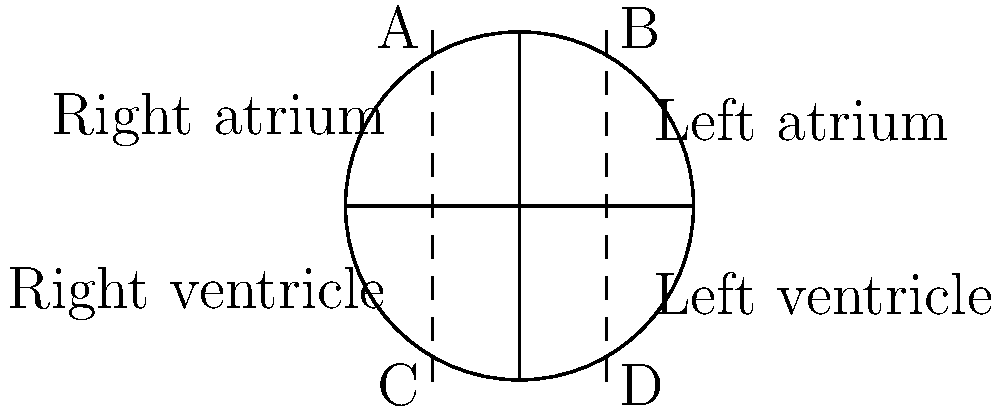In the diagram of the human heart, which chamber is responsible for pumping oxygenated blood to the body and is labeled as "D"? To answer this question, let's break down the structure of the heart and its functions:

1. The heart is divided into four main chambers: two atria (upper chambers) and two ventricles (lower chambers).

2. The right side of the heart (chambers A and C) deals with deoxygenated blood:
   - A: Right atrium receives deoxygenated blood from the body
   - C: Right ventricle pumps deoxygenated blood to the lungs

3. The left side of the heart (chambers B and D) deals with oxygenated blood:
   - B: Left atrium receives oxygenated blood from the lungs
   - D: Left ventricle pumps oxygenated blood to the body

4. In the diagram, chamber D is labeled as the "Left ventricle"

5. The left ventricle has the thickest walls of all heart chambers because it needs to generate enough pressure to pump oxygenated blood throughout the entire body.

Therefore, the chamber responsible for pumping oxygenated blood to the body and labeled as "D" in the diagram is the left ventricle.
Answer: Left ventricle 